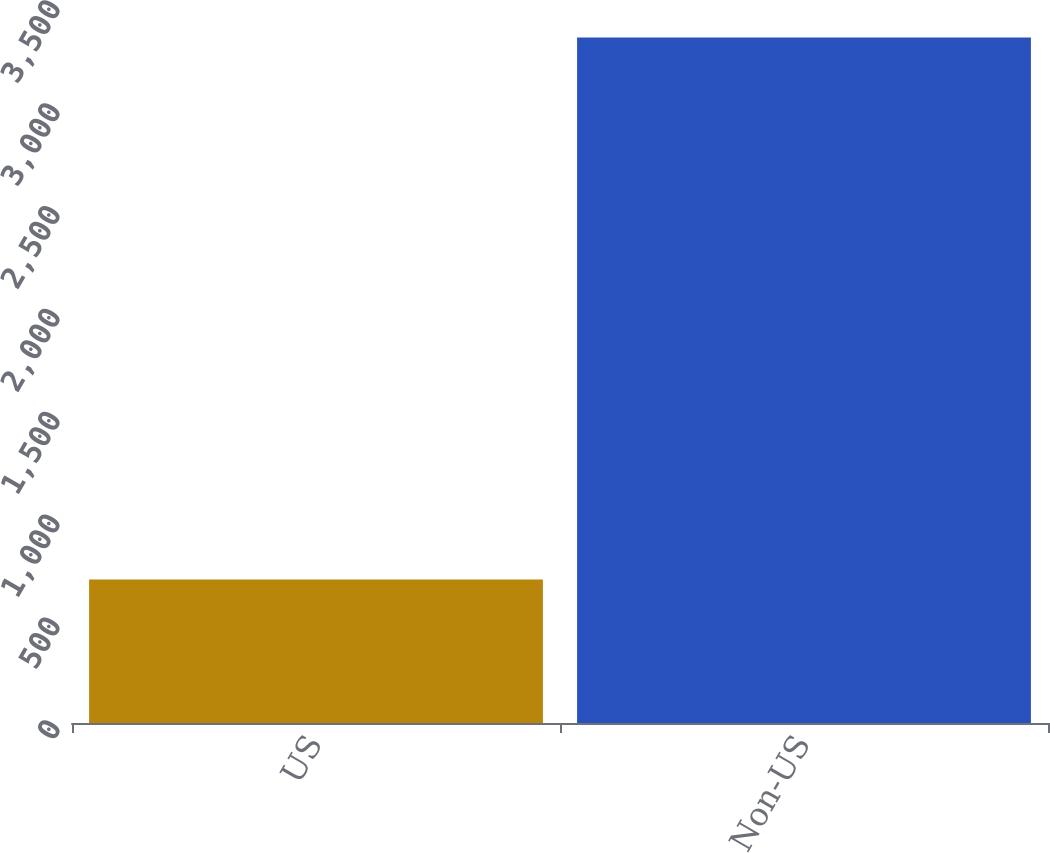Convert chart to OTSL. <chart><loc_0><loc_0><loc_500><loc_500><bar_chart><fcel>US<fcel>Non-US<nl><fcel>697<fcel>3332<nl></chart> 